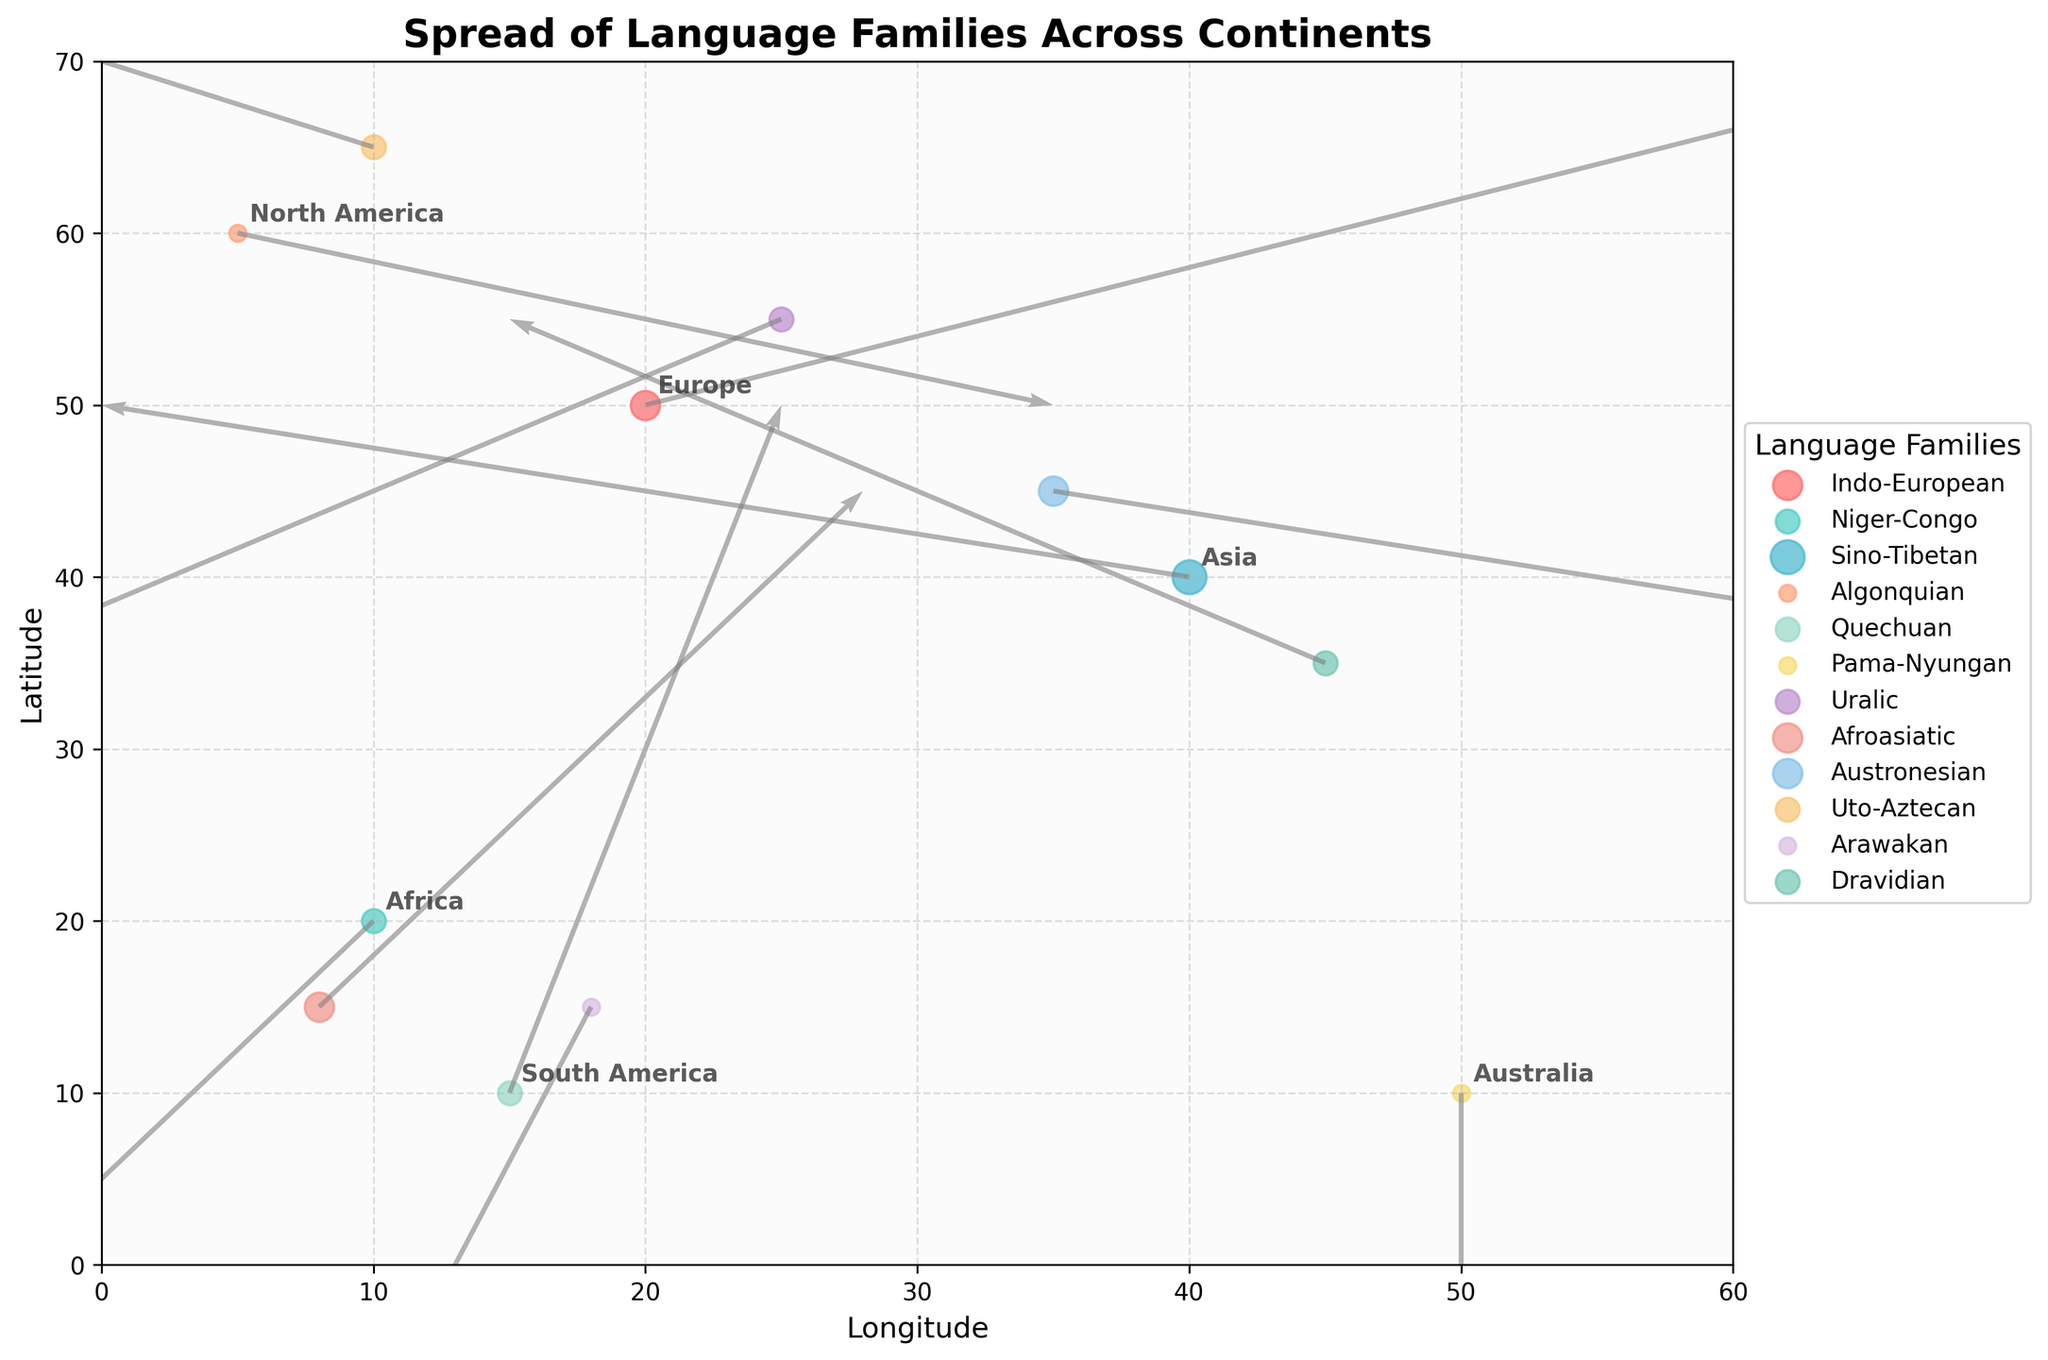What's the title of the figure? The title is clearly written at the top of the plot and provides a summary of what the plot is about.
Answer: Spread of Language Families Across Continents Which continent shows the strongest linguistic diffusion arrow? By looking at the length and direction of the arrows, the strongest arrow can be identified.
Answer: Asia How many language families are represented in Europe based on the plot? The legend and the plot can be used to identify language families represented in Europe.
Answer: Two Which family in South America has a downward diffusion arrow? Observing the arrows originating from South America and their directions helps identify the family with a downward-pointing arrow.
Answer: Arawakan What is the approximate latitude and longitude of the Austronesian family's origin point? By locating the Austronesian point in the Asia region on the plot, the approximate coordinates can be estimated.
Answer: (35, 45) Which language family in Africa has the arrow pointing upwards? Evaluate the arrows originating from Africa and observe the direction for the one pointing upwards.
Answer: Afroasiatic Compare the spread direction of Indo-European and Uralic language families in Europe. Which one is spreading southward? Identify the arrows from Europe for both families and compare their directions to determine which is pointing southward.
Answer: Uralic What is the longitude and latitude of the starting point of the Pama-Nyungan language family's diffusion arrow, and what is its general direction? Locate the starting point of the Pama-Nyungan family and observe its arrow’s direction.
Answer: (50, 10), downward direction Between Quechuan and Algonquian language families, which one shows stronger linguistic diffusion based on arrow strength? Comparing the lengths and the thickness of the arrows of Quechuan and Algonquian families helps identify the stronger one.
Answer: Quechuan Which language family in Asia has a diffusion arrow with both negative longitude and positive latitude change? Look for the arrow starting from Asia where both the change in longitude (DX) is negative and the change in latitude (DY) is positive.
Answer: Dravidian 